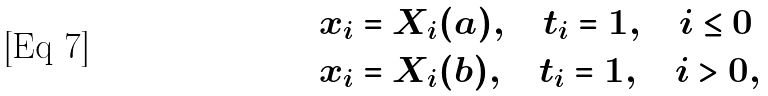<formula> <loc_0><loc_0><loc_500><loc_500>& x _ { i } = X _ { i } ( a ) , \quad t _ { i } = 1 , \quad i \leq 0 \\ & x _ { i } = X _ { i } ( b ) , \quad t _ { i } = 1 , \quad i > 0 ,</formula> 